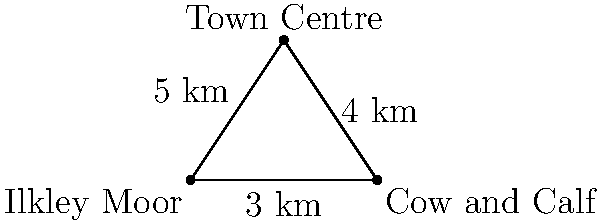In this simple plan of Ilkley, three landmarks form a right-angled triangle: Ilkley Moor, the Cow and Calf rocks, and the Town Centre. The distance between Ilkley Moor and the Cow and Calf is 3 km, and the distance from the Cow and Calf to the Town Centre is 4 km. If the distance from Ilkley Moor to the Town Centre is 5 km, what is the angle (in degrees, rounded to the nearest whole number) between the lines connecting Ilkley Moor to the Cow and Calf and Ilkley Moor to the Town Centre? Let's approach this step-by-step:

1) First, we recognize that we have a right-angled triangle, with the right angle at the Cow and Calf rocks.

2) We know all three sides of this triangle:
   - Ilkley Moor to Cow and Calf: 3 km
   - Cow and Calf to Town Centre: 4 km
   - Ilkley Moor to Town Centre: 5 km

3) This is a 3-4-5 right triangle, which is a special case where the sides form a Pythagorean triple.

4) To find the angle between Ilkley Moor to Cow and Calf and Ilkley Moor to Town Centre, we can use the cosine function.

5) In a right triangle, $\cos \theta = \frac{\text{adjacent}}{\text{hypotenuse}}$

6) In our case, the adjacent side is 3 km and the hypotenuse is 5 km.

7) So, $\cos \theta = \frac{3}{5}$

8) To find $\theta$, we need to take the inverse cosine (arccos):

   $\theta = \arccos(\frac{3}{5})$

9) Using a calculator or computer:

   $\theta \approx 53.13010235415598$ degrees

10) Rounding to the nearest whole number: 53 degrees
Answer: 53 degrees 